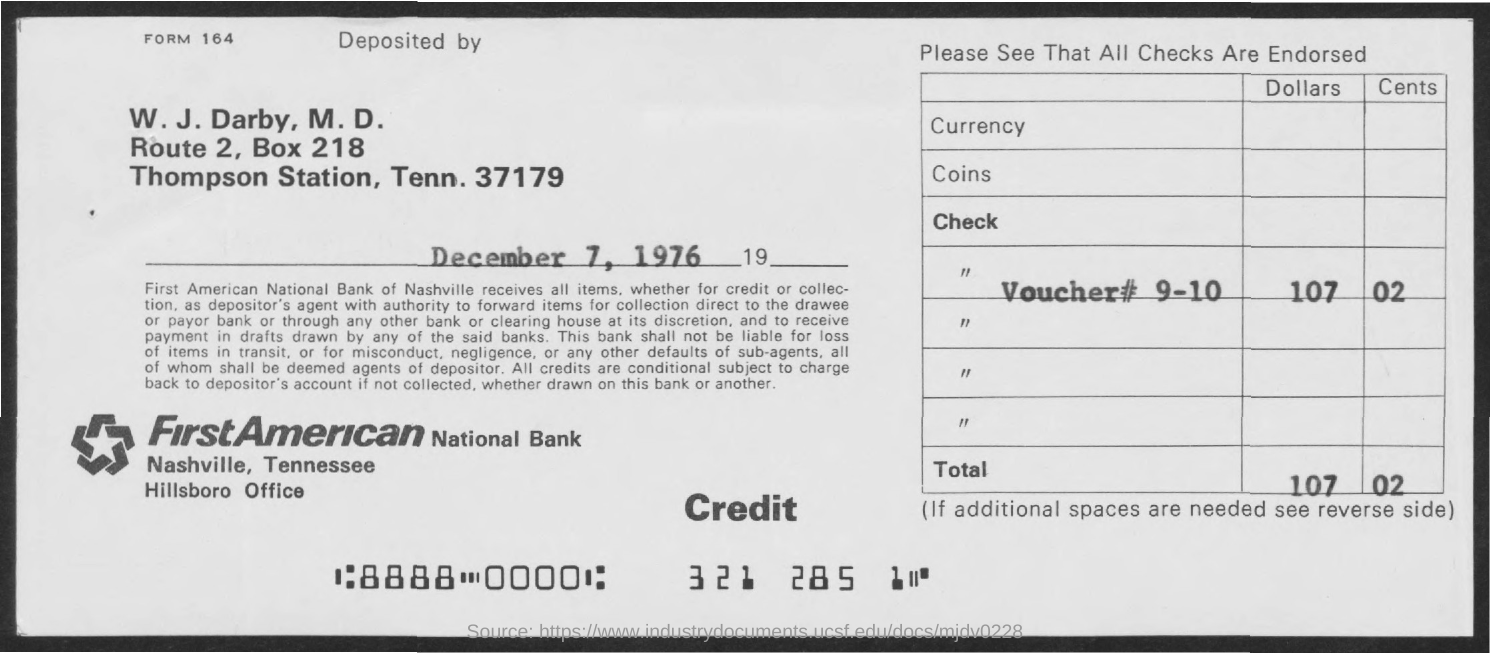Highlight a few significant elements in this photo. The total is 107.02, which is a decimal number. The document indicates that the date is December 7, 1976. 